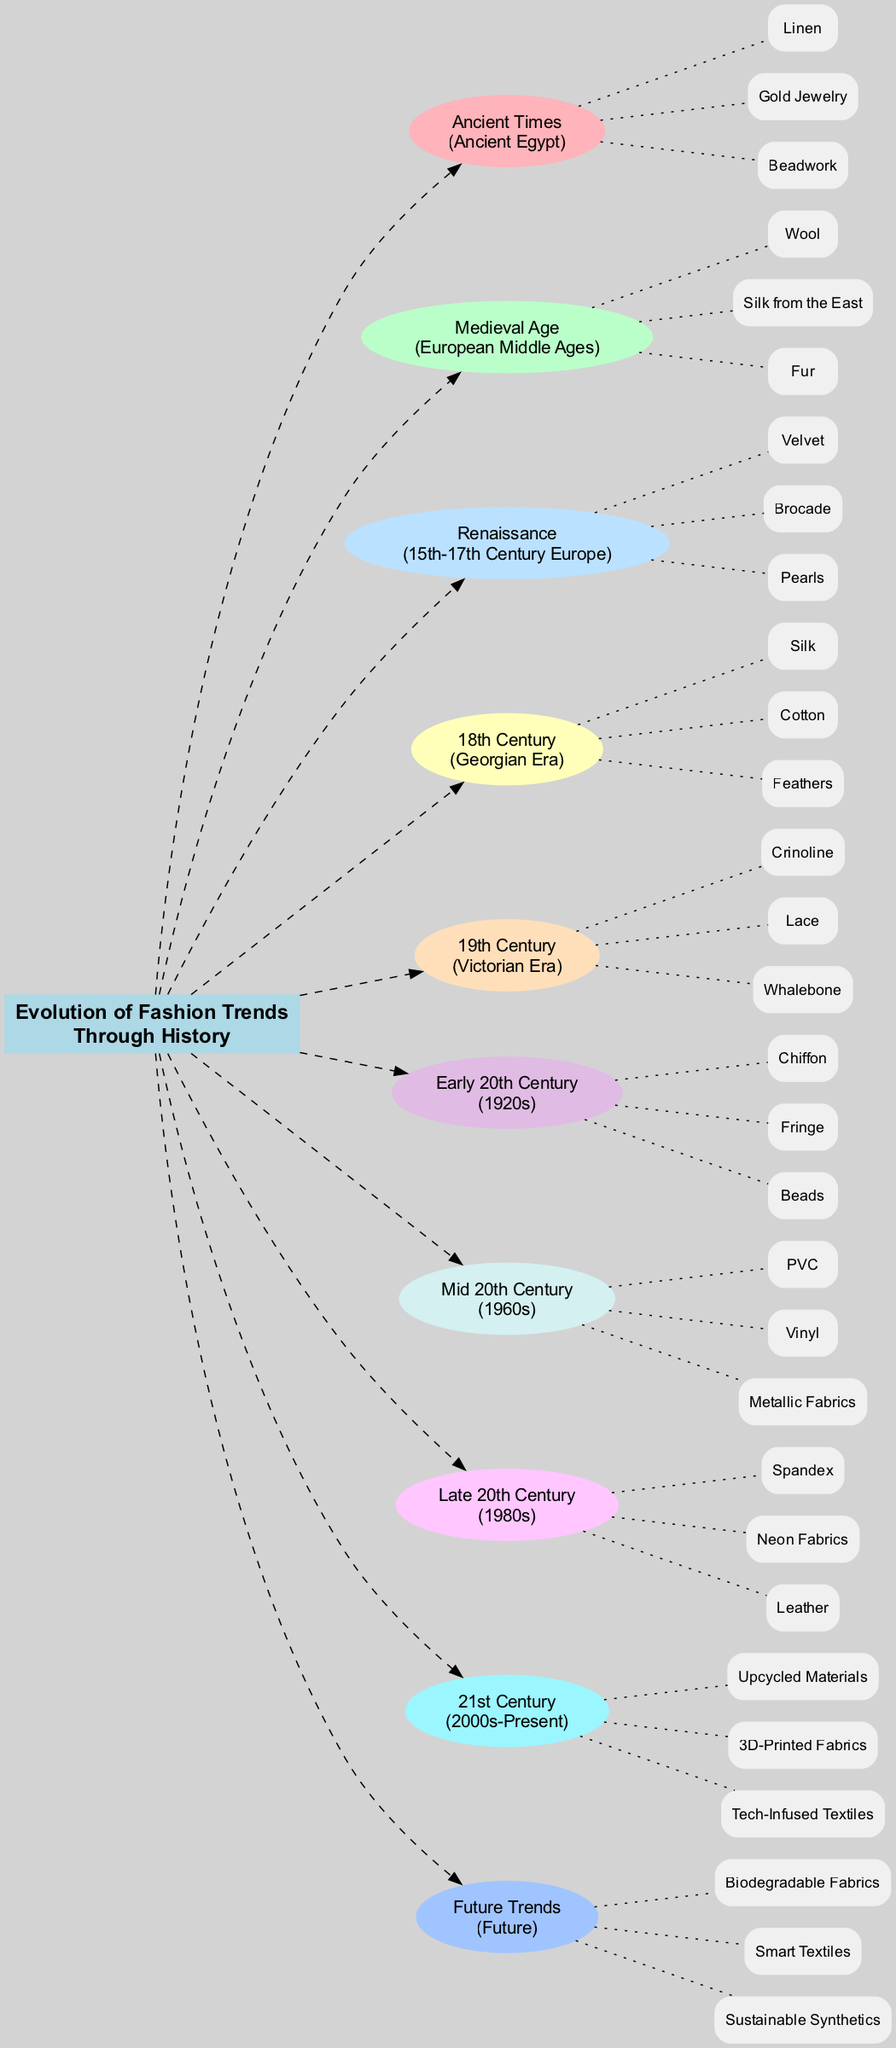What era is represented by unconventional materials like PVC and Vinyl? By looking at the diagram, we can identify the "Mid 20th Century" section which corresponds to the 1960s. Unconventional materials listed here include PVC and Vinyl, indicating this specific era of fashion trends.
Answer: 1960s How many unconventional materials are listed for the Victorian Era? In the diagram, under the "19th Century" section labeled as the Victorian Era, there are three unconventional materials mentioned: Crinoline, Lace, and Whalebone. Counting these materials gives us the answer.
Answer: 3 What are the unconventional materials used during the Ancient Egyptian era? From the diagram, in the "Ancient Times" section, the unconventional materials listed for Ancient Egypt are Linen, Gold Jewelry, and Beadwork. This information is explicitly given in the corresponding section of the diagram.
Answer: Linen, Gold Jewelry, Beadwork Which fashion trend era introduced upcycled materials? Looking at the timeline in the diagram, upcycled materials are linked to the "21st Century" era, which spans from the 2000s to the present day. Thus, the corresponding fashion trend era is identified as such.
Answer: 21st Century How many eras are represented in the diagram? To find the number of eras, we can count the distinct sections in the diagram, which includes Ancient Times, Medieval Age, Renaissance, 18th Century, 19th Century, Early 20th Century, Mid 20th Century, Late 20th Century, 21st Century, and Future Trends. This totals to ten different eras.
Answer: 10 What is the main connection type used between eras and their unconventional materials? Analyzing the diagram, the connection type used is the dotted line. Each era is connected to its respective unconventional materials through these dotted edges, indicating the relationship between the two components.
Answer: Dotted line Which decade in the 20th century is known for the introduction of Chiffon and Beads? The "Early 20th Century" section corresponds to the 1920s in the diagram. The unconventional materials listed for this era include Chiffon and Fringe, confirming the answer as the 1920s.
Answer: 1920s What unconventional material is associated with the Georgian Era? From the diagram, in the "18th Century" section labeled as the Georgian Era, the unconventional materials listed include Silk, Cotton, and Feathers. Thus, these materials are directly associated with this era.
Answer: Silk, Cotton, Feathers 